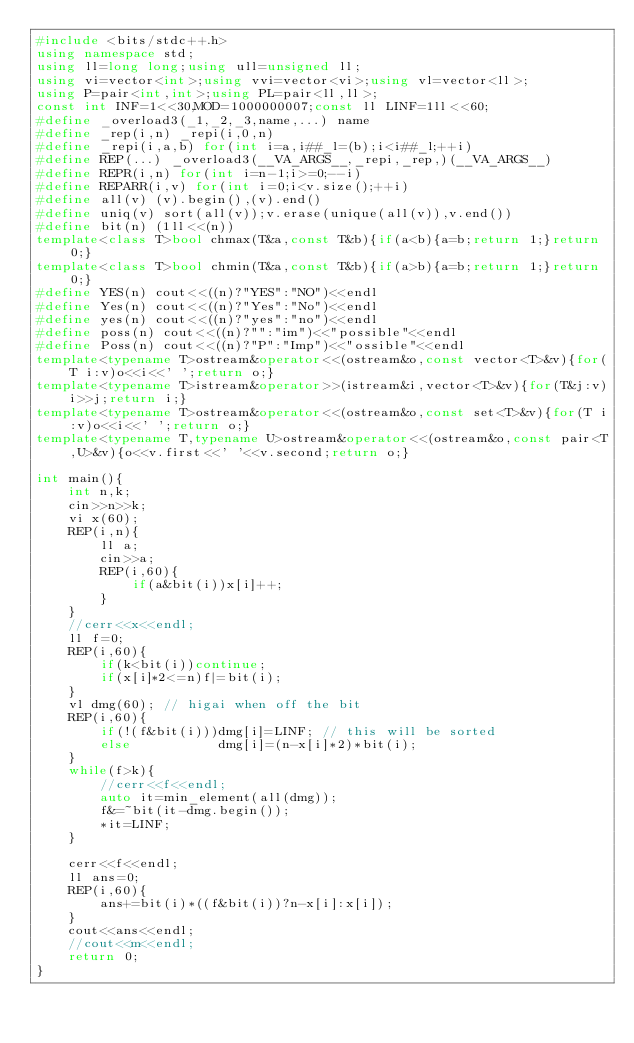Convert code to text. <code><loc_0><loc_0><loc_500><loc_500><_C++_>#include <bits/stdc++.h>
using namespace std;
using ll=long long;using ull=unsigned ll;
using vi=vector<int>;using vvi=vector<vi>;using vl=vector<ll>;
using P=pair<int,int>;using PL=pair<ll,ll>;
const int INF=1<<30,MOD=1000000007;const ll LINF=1ll<<60;
#define _overload3(_1,_2,_3,name,...) name
#define _rep(i,n) _repi(i,0,n)
#define _repi(i,a,b) for(int i=a,i##_l=(b);i<i##_l;++i)
#define REP(...) _overload3(__VA_ARGS__,_repi,_rep,)(__VA_ARGS__)
#define REPR(i,n) for(int i=n-1;i>=0;--i)
#define REPARR(i,v) for(int i=0;i<v.size();++i)
#define all(v) (v).begin(),(v).end()
#define uniq(v) sort(all(v));v.erase(unique(all(v)),v.end())
#define bit(n) (1ll<<(n))
template<class T>bool chmax(T&a,const T&b){if(a<b){a=b;return 1;}return 0;}
template<class T>bool chmin(T&a,const T&b){if(a>b){a=b;return 1;}return 0;}
#define YES(n) cout<<((n)?"YES":"NO")<<endl
#define Yes(n) cout<<((n)?"Yes":"No")<<endl
#define yes(n) cout<<((n)?"yes":"no")<<endl
#define poss(n) cout<<((n)?"":"im")<<"possible"<<endl
#define Poss(n) cout<<((n)?"P":"Imp")<<"ossible"<<endl
template<typename T>ostream&operator<<(ostream&o,const vector<T>&v){for(T i:v)o<<i<<' ';return o;}
template<typename T>istream&operator>>(istream&i,vector<T>&v){for(T&j:v)i>>j;return i;}
template<typename T>ostream&operator<<(ostream&o,const set<T>&v){for(T i:v)o<<i<<' ';return o;}
template<typename T,typename U>ostream&operator<<(ostream&o,const pair<T,U>&v){o<<v.first<<' '<<v.second;return o;}

int main(){
    int n,k;
    cin>>n>>k;
    vi x(60);
    REP(i,n){
        ll a;
        cin>>a;
        REP(i,60){
            if(a&bit(i))x[i]++;
        }
    }
    //cerr<<x<<endl;
    ll f=0;
    REP(i,60){
        if(k<bit(i))continue;
        if(x[i]*2<=n)f|=bit(i);
    }
    vl dmg(60); // higai when off the bit
    REP(i,60){
        if(!(f&bit(i)))dmg[i]=LINF; // this will be sorted
        else           dmg[i]=(n-x[i]*2)*bit(i);
    }
    while(f>k){
        //cerr<<f<<endl;
        auto it=min_element(all(dmg));
        f&=~bit(it-dmg.begin());
        *it=LINF;
    }

    cerr<<f<<endl;
    ll ans=0;
    REP(i,60){
        ans+=bit(i)*((f&bit(i))?n-x[i]:x[i]);
    }
    cout<<ans<<endl;
    //cout<<m<<endl;
    return 0;
}
</code> 